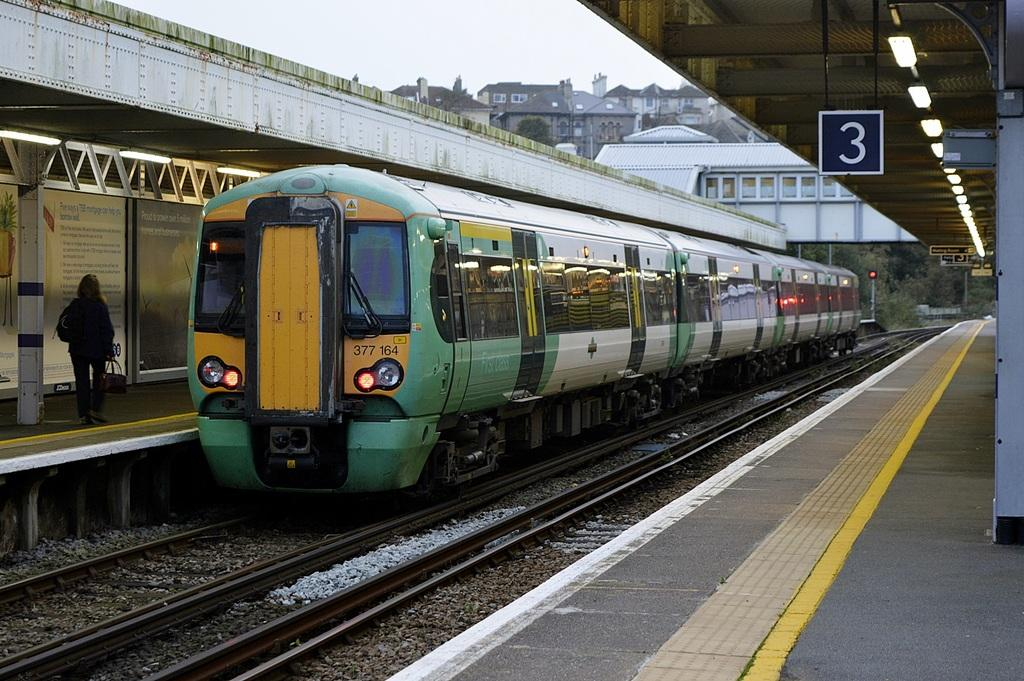<image>
Provide a brief description of the given image. A green and yellow train stopped at station 3. 